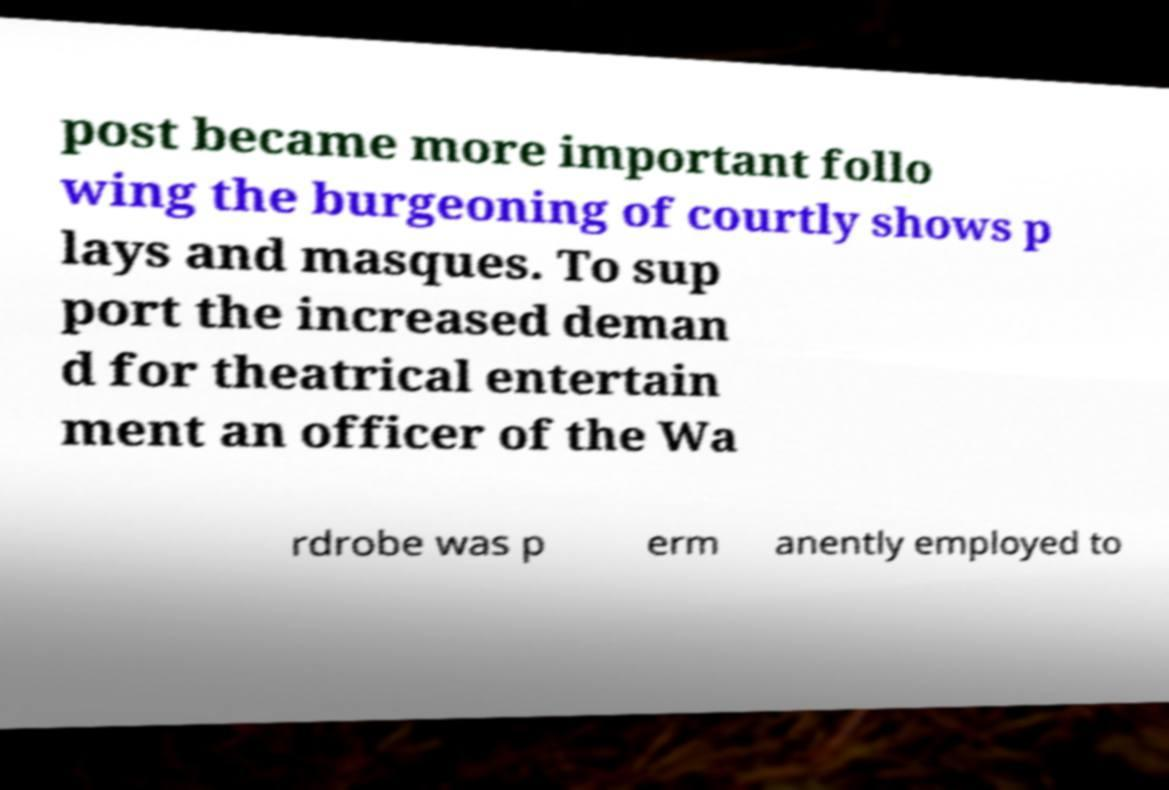What messages or text are displayed in this image? I need them in a readable, typed format. post became more important follo wing the burgeoning of courtly shows p lays and masques. To sup port the increased deman d for theatrical entertain ment an officer of the Wa rdrobe was p erm anently employed to 